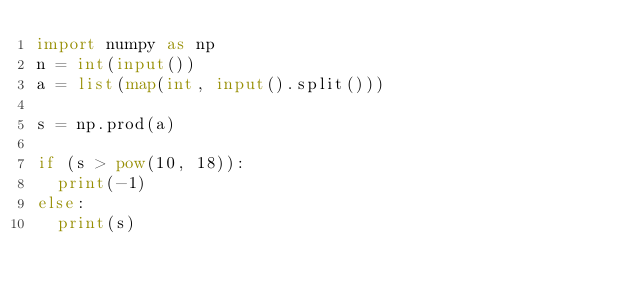<code> <loc_0><loc_0><loc_500><loc_500><_Python_>import numpy as np
n = int(input())
a = list(map(int, input().split()))

s = np.prod(a)

if (s > pow(10, 18)):
  print(-1)
else:
  print(s)</code> 